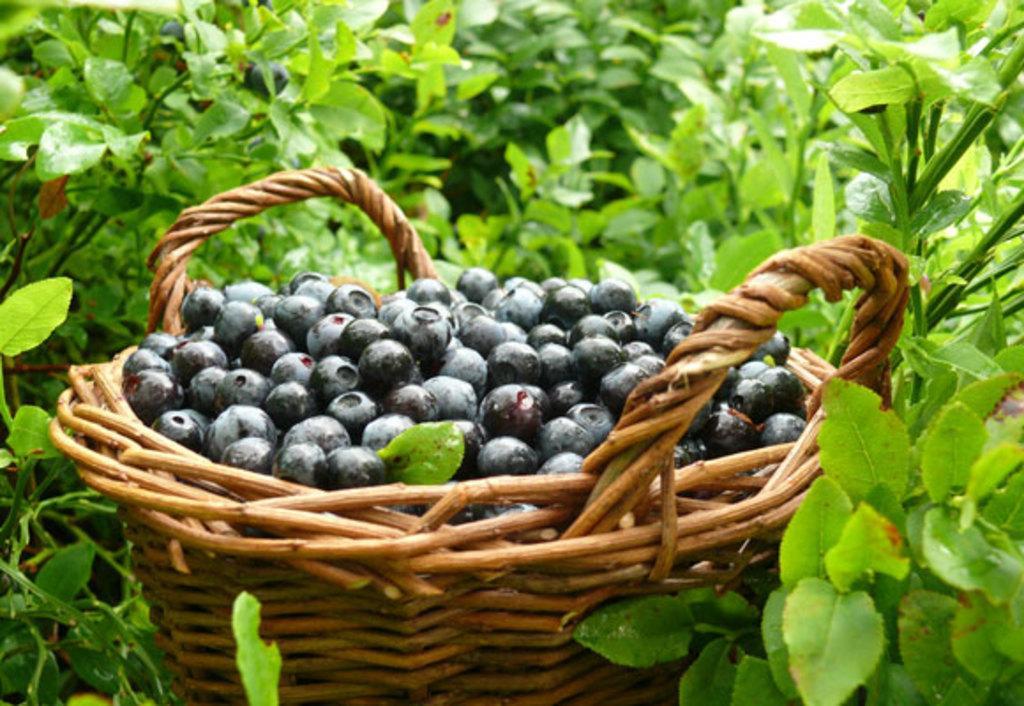Describe this image in one or two sentences. In this image there are some berries filled in the basket in the middle of this image and there are some plants in the background. 